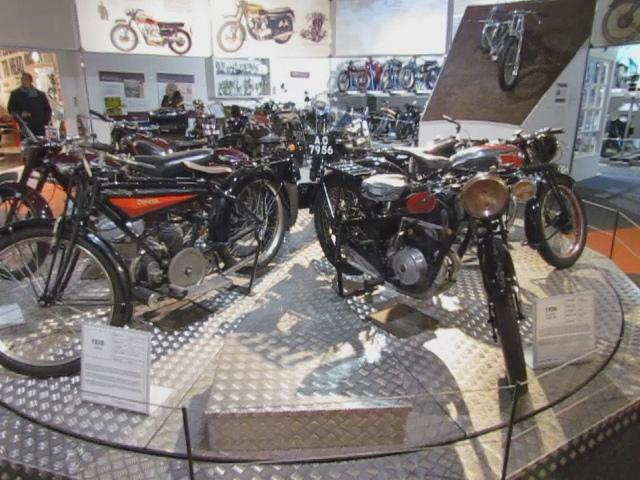What sort of shop is this? Please explain your reasoning. motorcycle sales. There are bikes on a pedestal for viewing inside a showroom. 